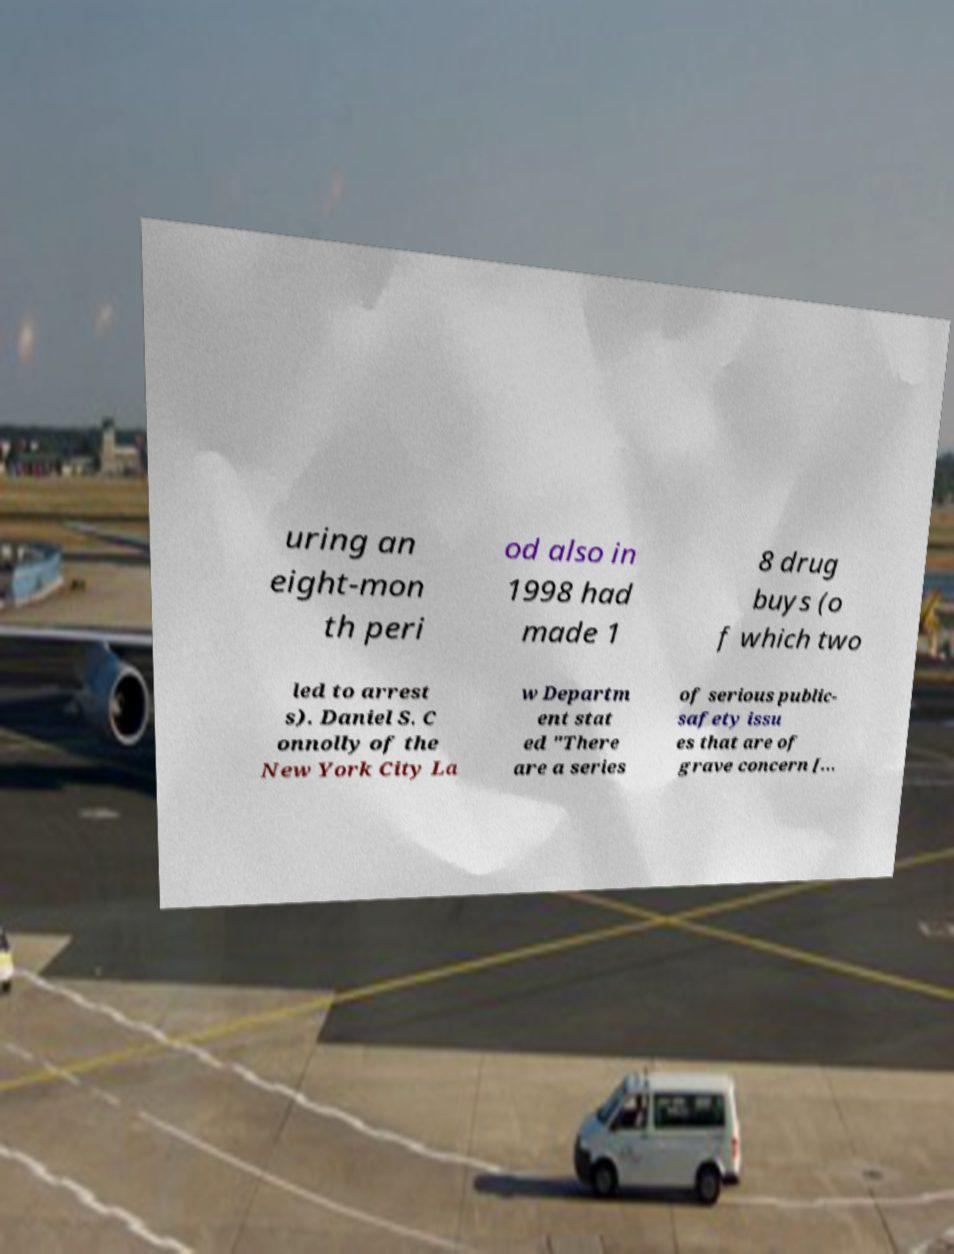Please read and relay the text visible in this image. What does it say? uring an eight-mon th peri od also in 1998 had made 1 8 drug buys (o f which two led to arrest s). Daniel S. C onnolly of the New York City La w Departm ent stat ed "There are a series of serious public- safety issu es that are of grave concern [... 